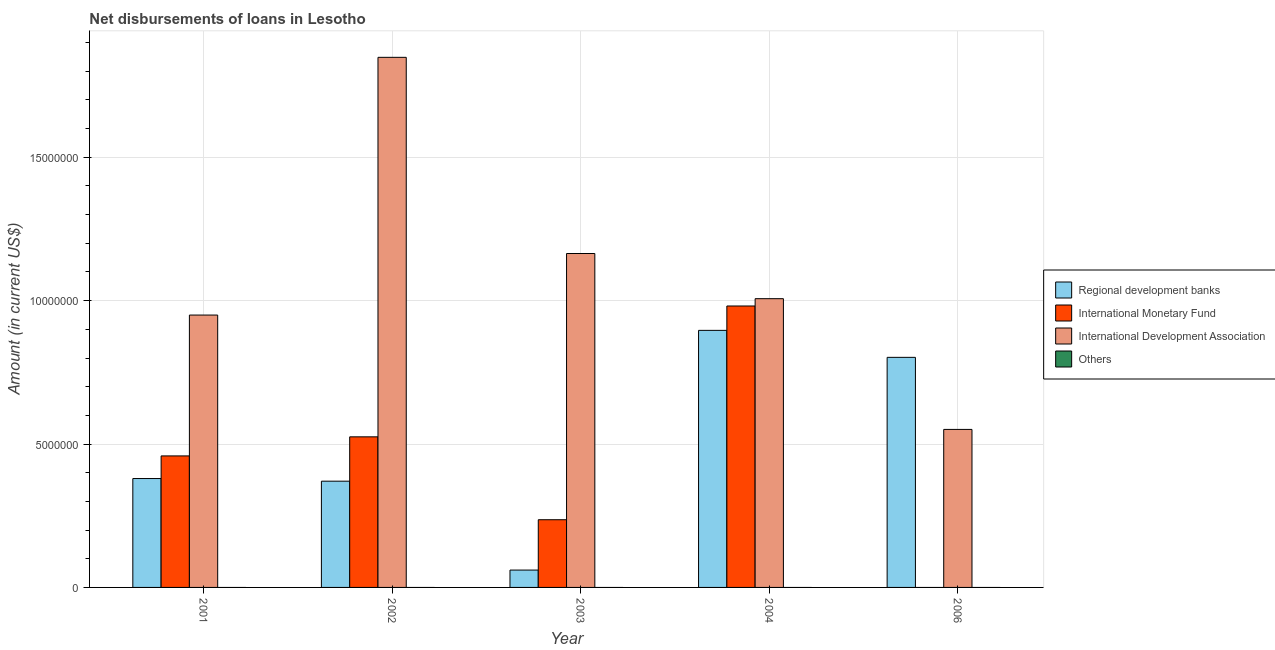How many different coloured bars are there?
Provide a short and direct response. 3. How many groups of bars are there?
Offer a very short reply. 5. Are the number of bars on each tick of the X-axis equal?
Your answer should be very brief. No. How many bars are there on the 5th tick from the left?
Provide a succinct answer. 2. In how many cases, is the number of bars for a given year not equal to the number of legend labels?
Keep it short and to the point. 5. Across all years, what is the maximum amount of loan disimbursed by international monetary fund?
Offer a terse response. 9.81e+06. What is the total amount of loan disimbursed by international monetary fund in the graph?
Keep it short and to the point. 2.20e+07. What is the difference between the amount of loan disimbursed by international development association in 2001 and that in 2006?
Your response must be concise. 3.99e+06. What is the difference between the amount of loan disimbursed by international monetary fund in 2004 and the amount of loan disimbursed by other organisations in 2002?
Provide a succinct answer. 4.56e+06. What is the average amount of loan disimbursed by international monetary fund per year?
Provide a succinct answer. 4.40e+06. In how many years, is the amount of loan disimbursed by international development association greater than 2000000 US$?
Your answer should be compact. 5. What is the ratio of the amount of loan disimbursed by regional development banks in 2001 to that in 2006?
Make the answer very short. 0.47. Is the amount of loan disimbursed by international development association in 2003 less than that in 2006?
Your response must be concise. No. Is the difference between the amount of loan disimbursed by international monetary fund in 2001 and 2003 greater than the difference between the amount of loan disimbursed by other organisations in 2001 and 2003?
Provide a succinct answer. No. What is the difference between the highest and the second highest amount of loan disimbursed by international development association?
Your answer should be compact. 6.84e+06. What is the difference between the highest and the lowest amount of loan disimbursed by international development association?
Keep it short and to the point. 1.30e+07. In how many years, is the amount of loan disimbursed by international development association greater than the average amount of loan disimbursed by international development association taken over all years?
Your answer should be compact. 2. Is the sum of the amount of loan disimbursed by international development association in 2004 and 2006 greater than the maximum amount of loan disimbursed by regional development banks across all years?
Keep it short and to the point. No. Is it the case that in every year, the sum of the amount of loan disimbursed by international monetary fund and amount of loan disimbursed by regional development banks is greater than the sum of amount of loan disimbursed by international development association and amount of loan disimbursed by other organisations?
Give a very brief answer. No. Is it the case that in every year, the sum of the amount of loan disimbursed by regional development banks and amount of loan disimbursed by international monetary fund is greater than the amount of loan disimbursed by international development association?
Give a very brief answer. No. How many bars are there?
Make the answer very short. 14. Are all the bars in the graph horizontal?
Ensure brevity in your answer.  No. How many years are there in the graph?
Offer a very short reply. 5. Are the values on the major ticks of Y-axis written in scientific E-notation?
Keep it short and to the point. No. Does the graph contain grids?
Provide a succinct answer. Yes. Where does the legend appear in the graph?
Your response must be concise. Center right. How many legend labels are there?
Give a very brief answer. 4. What is the title of the graph?
Offer a terse response. Net disbursements of loans in Lesotho. What is the label or title of the X-axis?
Offer a very short reply. Year. What is the label or title of the Y-axis?
Make the answer very short. Amount (in current US$). What is the Amount (in current US$) in Regional development banks in 2001?
Provide a short and direct response. 3.80e+06. What is the Amount (in current US$) in International Monetary Fund in 2001?
Offer a terse response. 4.59e+06. What is the Amount (in current US$) of International Development Association in 2001?
Offer a very short reply. 9.50e+06. What is the Amount (in current US$) in Regional development banks in 2002?
Your answer should be compact. 3.70e+06. What is the Amount (in current US$) in International Monetary Fund in 2002?
Your answer should be very brief. 5.25e+06. What is the Amount (in current US$) of International Development Association in 2002?
Your response must be concise. 1.85e+07. What is the Amount (in current US$) of Others in 2002?
Your answer should be compact. 0. What is the Amount (in current US$) of Regional development banks in 2003?
Keep it short and to the point. 6.05e+05. What is the Amount (in current US$) in International Monetary Fund in 2003?
Make the answer very short. 2.36e+06. What is the Amount (in current US$) of International Development Association in 2003?
Your response must be concise. 1.16e+07. What is the Amount (in current US$) in Others in 2003?
Your response must be concise. 0. What is the Amount (in current US$) of Regional development banks in 2004?
Offer a very short reply. 8.96e+06. What is the Amount (in current US$) in International Monetary Fund in 2004?
Ensure brevity in your answer.  9.81e+06. What is the Amount (in current US$) of International Development Association in 2004?
Provide a succinct answer. 1.01e+07. What is the Amount (in current US$) of Regional development banks in 2006?
Provide a short and direct response. 8.02e+06. What is the Amount (in current US$) of International Development Association in 2006?
Provide a short and direct response. 5.51e+06. What is the Amount (in current US$) of Others in 2006?
Keep it short and to the point. 0. Across all years, what is the maximum Amount (in current US$) of Regional development banks?
Provide a short and direct response. 8.96e+06. Across all years, what is the maximum Amount (in current US$) of International Monetary Fund?
Offer a very short reply. 9.81e+06. Across all years, what is the maximum Amount (in current US$) of International Development Association?
Your response must be concise. 1.85e+07. Across all years, what is the minimum Amount (in current US$) of Regional development banks?
Your response must be concise. 6.05e+05. Across all years, what is the minimum Amount (in current US$) of International Development Association?
Your answer should be very brief. 5.51e+06. What is the total Amount (in current US$) in Regional development banks in the graph?
Keep it short and to the point. 2.51e+07. What is the total Amount (in current US$) in International Monetary Fund in the graph?
Provide a short and direct response. 2.20e+07. What is the total Amount (in current US$) of International Development Association in the graph?
Your response must be concise. 5.52e+07. What is the total Amount (in current US$) in Others in the graph?
Provide a succinct answer. 0. What is the difference between the Amount (in current US$) in Regional development banks in 2001 and that in 2002?
Provide a short and direct response. 9.20e+04. What is the difference between the Amount (in current US$) of International Monetary Fund in 2001 and that in 2002?
Your answer should be compact. -6.65e+05. What is the difference between the Amount (in current US$) in International Development Association in 2001 and that in 2002?
Your answer should be compact. -8.99e+06. What is the difference between the Amount (in current US$) in Regional development banks in 2001 and that in 2003?
Provide a short and direct response. 3.19e+06. What is the difference between the Amount (in current US$) of International Monetary Fund in 2001 and that in 2003?
Your answer should be compact. 2.22e+06. What is the difference between the Amount (in current US$) of International Development Association in 2001 and that in 2003?
Your answer should be very brief. -2.15e+06. What is the difference between the Amount (in current US$) in Regional development banks in 2001 and that in 2004?
Your answer should be compact. -5.17e+06. What is the difference between the Amount (in current US$) in International Monetary Fund in 2001 and that in 2004?
Offer a terse response. -5.23e+06. What is the difference between the Amount (in current US$) of International Development Association in 2001 and that in 2004?
Provide a succinct answer. -5.71e+05. What is the difference between the Amount (in current US$) in Regional development banks in 2001 and that in 2006?
Provide a short and direct response. -4.23e+06. What is the difference between the Amount (in current US$) of International Development Association in 2001 and that in 2006?
Offer a terse response. 3.99e+06. What is the difference between the Amount (in current US$) of Regional development banks in 2002 and that in 2003?
Your answer should be very brief. 3.10e+06. What is the difference between the Amount (in current US$) in International Monetary Fund in 2002 and that in 2003?
Your answer should be compact. 2.89e+06. What is the difference between the Amount (in current US$) of International Development Association in 2002 and that in 2003?
Make the answer very short. 6.84e+06. What is the difference between the Amount (in current US$) of Regional development banks in 2002 and that in 2004?
Keep it short and to the point. -5.26e+06. What is the difference between the Amount (in current US$) in International Monetary Fund in 2002 and that in 2004?
Your answer should be compact. -4.56e+06. What is the difference between the Amount (in current US$) in International Development Association in 2002 and that in 2004?
Make the answer very short. 8.42e+06. What is the difference between the Amount (in current US$) of Regional development banks in 2002 and that in 2006?
Offer a terse response. -4.32e+06. What is the difference between the Amount (in current US$) of International Development Association in 2002 and that in 2006?
Make the answer very short. 1.30e+07. What is the difference between the Amount (in current US$) in Regional development banks in 2003 and that in 2004?
Provide a succinct answer. -8.36e+06. What is the difference between the Amount (in current US$) of International Monetary Fund in 2003 and that in 2004?
Offer a very short reply. -7.45e+06. What is the difference between the Amount (in current US$) of International Development Association in 2003 and that in 2004?
Keep it short and to the point. 1.58e+06. What is the difference between the Amount (in current US$) in Regional development banks in 2003 and that in 2006?
Offer a very short reply. -7.42e+06. What is the difference between the Amount (in current US$) in International Development Association in 2003 and that in 2006?
Offer a very short reply. 6.13e+06. What is the difference between the Amount (in current US$) in Regional development banks in 2004 and that in 2006?
Ensure brevity in your answer.  9.41e+05. What is the difference between the Amount (in current US$) of International Development Association in 2004 and that in 2006?
Offer a terse response. 4.56e+06. What is the difference between the Amount (in current US$) in Regional development banks in 2001 and the Amount (in current US$) in International Monetary Fund in 2002?
Give a very brief answer. -1.45e+06. What is the difference between the Amount (in current US$) of Regional development banks in 2001 and the Amount (in current US$) of International Development Association in 2002?
Your response must be concise. -1.47e+07. What is the difference between the Amount (in current US$) of International Monetary Fund in 2001 and the Amount (in current US$) of International Development Association in 2002?
Your answer should be compact. -1.39e+07. What is the difference between the Amount (in current US$) in Regional development banks in 2001 and the Amount (in current US$) in International Monetary Fund in 2003?
Your response must be concise. 1.44e+06. What is the difference between the Amount (in current US$) of Regional development banks in 2001 and the Amount (in current US$) of International Development Association in 2003?
Make the answer very short. -7.85e+06. What is the difference between the Amount (in current US$) of International Monetary Fund in 2001 and the Amount (in current US$) of International Development Association in 2003?
Provide a short and direct response. -7.06e+06. What is the difference between the Amount (in current US$) of Regional development banks in 2001 and the Amount (in current US$) of International Monetary Fund in 2004?
Offer a very short reply. -6.02e+06. What is the difference between the Amount (in current US$) in Regional development banks in 2001 and the Amount (in current US$) in International Development Association in 2004?
Ensure brevity in your answer.  -6.27e+06. What is the difference between the Amount (in current US$) of International Monetary Fund in 2001 and the Amount (in current US$) of International Development Association in 2004?
Keep it short and to the point. -5.48e+06. What is the difference between the Amount (in current US$) in Regional development banks in 2001 and the Amount (in current US$) in International Development Association in 2006?
Offer a terse response. -1.71e+06. What is the difference between the Amount (in current US$) in International Monetary Fund in 2001 and the Amount (in current US$) in International Development Association in 2006?
Offer a terse response. -9.24e+05. What is the difference between the Amount (in current US$) of Regional development banks in 2002 and the Amount (in current US$) of International Monetary Fund in 2003?
Keep it short and to the point. 1.34e+06. What is the difference between the Amount (in current US$) of Regional development banks in 2002 and the Amount (in current US$) of International Development Association in 2003?
Offer a very short reply. -7.94e+06. What is the difference between the Amount (in current US$) of International Monetary Fund in 2002 and the Amount (in current US$) of International Development Association in 2003?
Your response must be concise. -6.39e+06. What is the difference between the Amount (in current US$) of Regional development banks in 2002 and the Amount (in current US$) of International Monetary Fund in 2004?
Ensure brevity in your answer.  -6.11e+06. What is the difference between the Amount (in current US$) of Regional development banks in 2002 and the Amount (in current US$) of International Development Association in 2004?
Keep it short and to the point. -6.36e+06. What is the difference between the Amount (in current US$) of International Monetary Fund in 2002 and the Amount (in current US$) of International Development Association in 2004?
Your response must be concise. -4.82e+06. What is the difference between the Amount (in current US$) of Regional development banks in 2002 and the Amount (in current US$) of International Development Association in 2006?
Offer a terse response. -1.80e+06. What is the difference between the Amount (in current US$) of International Monetary Fund in 2002 and the Amount (in current US$) of International Development Association in 2006?
Offer a very short reply. -2.59e+05. What is the difference between the Amount (in current US$) of Regional development banks in 2003 and the Amount (in current US$) of International Monetary Fund in 2004?
Provide a succinct answer. -9.21e+06. What is the difference between the Amount (in current US$) of Regional development banks in 2003 and the Amount (in current US$) of International Development Association in 2004?
Offer a very short reply. -9.46e+06. What is the difference between the Amount (in current US$) of International Monetary Fund in 2003 and the Amount (in current US$) of International Development Association in 2004?
Make the answer very short. -7.71e+06. What is the difference between the Amount (in current US$) in Regional development banks in 2003 and the Amount (in current US$) in International Development Association in 2006?
Offer a very short reply. -4.90e+06. What is the difference between the Amount (in current US$) of International Monetary Fund in 2003 and the Amount (in current US$) of International Development Association in 2006?
Offer a very short reply. -3.15e+06. What is the difference between the Amount (in current US$) of Regional development banks in 2004 and the Amount (in current US$) of International Development Association in 2006?
Offer a very short reply. 3.45e+06. What is the difference between the Amount (in current US$) in International Monetary Fund in 2004 and the Amount (in current US$) in International Development Association in 2006?
Make the answer very short. 4.30e+06. What is the average Amount (in current US$) in Regional development banks per year?
Ensure brevity in your answer.  5.02e+06. What is the average Amount (in current US$) of International Monetary Fund per year?
Provide a succinct answer. 4.40e+06. What is the average Amount (in current US$) in International Development Association per year?
Your response must be concise. 1.10e+07. In the year 2001, what is the difference between the Amount (in current US$) in Regional development banks and Amount (in current US$) in International Monetary Fund?
Offer a terse response. -7.89e+05. In the year 2001, what is the difference between the Amount (in current US$) of Regional development banks and Amount (in current US$) of International Development Association?
Your response must be concise. -5.70e+06. In the year 2001, what is the difference between the Amount (in current US$) in International Monetary Fund and Amount (in current US$) in International Development Association?
Offer a very short reply. -4.91e+06. In the year 2002, what is the difference between the Amount (in current US$) of Regional development banks and Amount (in current US$) of International Monetary Fund?
Offer a very short reply. -1.55e+06. In the year 2002, what is the difference between the Amount (in current US$) of Regional development banks and Amount (in current US$) of International Development Association?
Give a very brief answer. -1.48e+07. In the year 2002, what is the difference between the Amount (in current US$) in International Monetary Fund and Amount (in current US$) in International Development Association?
Provide a succinct answer. -1.32e+07. In the year 2003, what is the difference between the Amount (in current US$) of Regional development banks and Amount (in current US$) of International Monetary Fund?
Ensure brevity in your answer.  -1.76e+06. In the year 2003, what is the difference between the Amount (in current US$) in Regional development banks and Amount (in current US$) in International Development Association?
Provide a succinct answer. -1.10e+07. In the year 2003, what is the difference between the Amount (in current US$) of International Monetary Fund and Amount (in current US$) of International Development Association?
Provide a succinct answer. -9.28e+06. In the year 2004, what is the difference between the Amount (in current US$) in Regional development banks and Amount (in current US$) in International Monetary Fund?
Your answer should be very brief. -8.50e+05. In the year 2004, what is the difference between the Amount (in current US$) in Regional development banks and Amount (in current US$) in International Development Association?
Provide a short and direct response. -1.10e+06. In the year 2004, what is the difference between the Amount (in current US$) in International Monetary Fund and Amount (in current US$) in International Development Association?
Provide a succinct answer. -2.55e+05. In the year 2006, what is the difference between the Amount (in current US$) in Regional development banks and Amount (in current US$) in International Development Association?
Offer a very short reply. 2.51e+06. What is the ratio of the Amount (in current US$) in Regional development banks in 2001 to that in 2002?
Give a very brief answer. 1.02. What is the ratio of the Amount (in current US$) in International Monetary Fund in 2001 to that in 2002?
Provide a succinct answer. 0.87. What is the ratio of the Amount (in current US$) of International Development Association in 2001 to that in 2002?
Your answer should be very brief. 0.51. What is the ratio of the Amount (in current US$) in Regional development banks in 2001 to that in 2003?
Provide a short and direct response. 6.28. What is the ratio of the Amount (in current US$) in International Monetary Fund in 2001 to that in 2003?
Keep it short and to the point. 1.94. What is the ratio of the Amount (in current US$) in International Development Association in 2001 to that in 2003?
Your answer should be very brief. 0.82. What is the ratio of the Amount (in current US$) in Regional development banks in 2001 to that in 2004?
Give a very brief answer. 0.42. What is the ratio of the Amount (in current US$) in International Monetary Fund in 2001 to that in 2004?
Provide a short and direct response. 0.47. What is the ratio of the Amount (in current US$) in International Development Association in 2001 to that in 2004?
Your answer should be very brief. 0.94. What is the ratio of the Amount (in current US$) in Regional development banks in 2001 to that in 2006?
Provide a short and direct response. 0.47. What is the ratio of the Amount (in current US$) of International Development Association in 2001 to that in 2006?
Make the answer very short. 1.72. What is the ratio of the Amount (in current US$) of Regional development banks in 2002 to that in 2003?
Provide a succinct answer. 6.12. What is the ratio of the Amount (in current US$) of International Monetary Fund in 2002 to that in 2003?
Your answer should be compact. 2.22. What is the ratio of the Amount (in current US$) in International Development Association in 2002 to that in 2003?
Ensure brevity in your answer.  1.59. What is the ratio of the Amount (in current US$) in Regional development banks in 2002 to that in 2004?
Your answer should be compact. 0.41. What is the ratio of the Amount (in current US$) in International Monetary Fund in 2002 to that in 2004?
Offer a terse response. 0.54. What is the ratio of the Amount (in current US$) of International Development Association in 2002 to that in 2004?
Ensure brevity in your answer.  1.84. What is the ratio of the Amount (in current US$) in Regional development banks in 2002 to that in 2006?
Provide a succinct answer. 0.46. What is the ratio of the Amount (in current US$) in International Development Association in 2002 to that in 2006?
Ensure brevity in your answer.  3.35. What is the ratio of the Amount (in current US$) in Regional development banks in 2003 to that in 2004?
Make the answer very short. 0.07. What is the ratio of the Amount (in current US$) of International Monetary Fund in 2003 to that in 2004?
Ensure brevity in your answer.  0.24. What is the ratio of the Amount (in current US$) in International Development Association in 2003 to that in 2004?
Make the answer very short. 1.16. What is the ratio of the Amount (in current US$) in Regional development banks in 2003 to that in 2006?
Your answer should be very brief. 0.08. What is the ratio of the Amount (in current US$) in International Development Association in 2003 to that in 2006?
Ensure brevity in your answer.  2.11. What is the ratio of the Amount (in current US$) of Regional development banks in 2004 to that in 2006?
Your answer should be compact. 1.12. What is the ratio of the Amount (in current US$) of International Development Association in 2004 to that in 2006?
Offer a terse response. 1.83. What is the difference between the highest and the second highest Amount (in current US$) in Regional development banks?
Keep it short and to the point. 9.41e+05. What is the difference between the highest and the second highest Amount (in current US$) in International Monetary Fund?
Your answer should be very brief. 4.56e+06. What is the difference between the highest and the second highest Amount (in current US$) in International Development Association?
Your response must be concise. 6.84e+06. What is the difference between the highest and the lowest Amount (in current US$) of Regional development banks?
Your response must be concise. 8.36e+06. What is the difference between the highest and the lowest Amount (in current US$) of International Monetary Fund?
Ensure brevity in your answer.  9.81e+06. What is the difference between the highest and the lowest Amount (in current US$) of International Development Association?
Provide a succinct answer. 1.30e+07. 